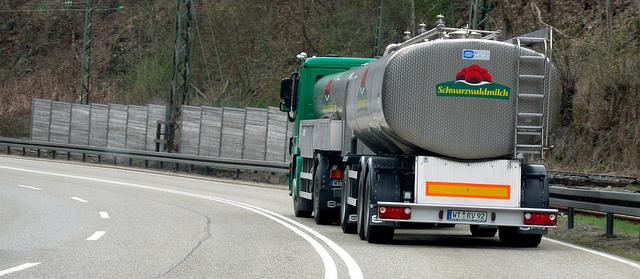Is the truck going down a steep hill?
Answer briefly. No. Does this truck have a ladder in the back?
Be succinct. Yes. What is this truck transporting?
Answer briefly. Gas. 